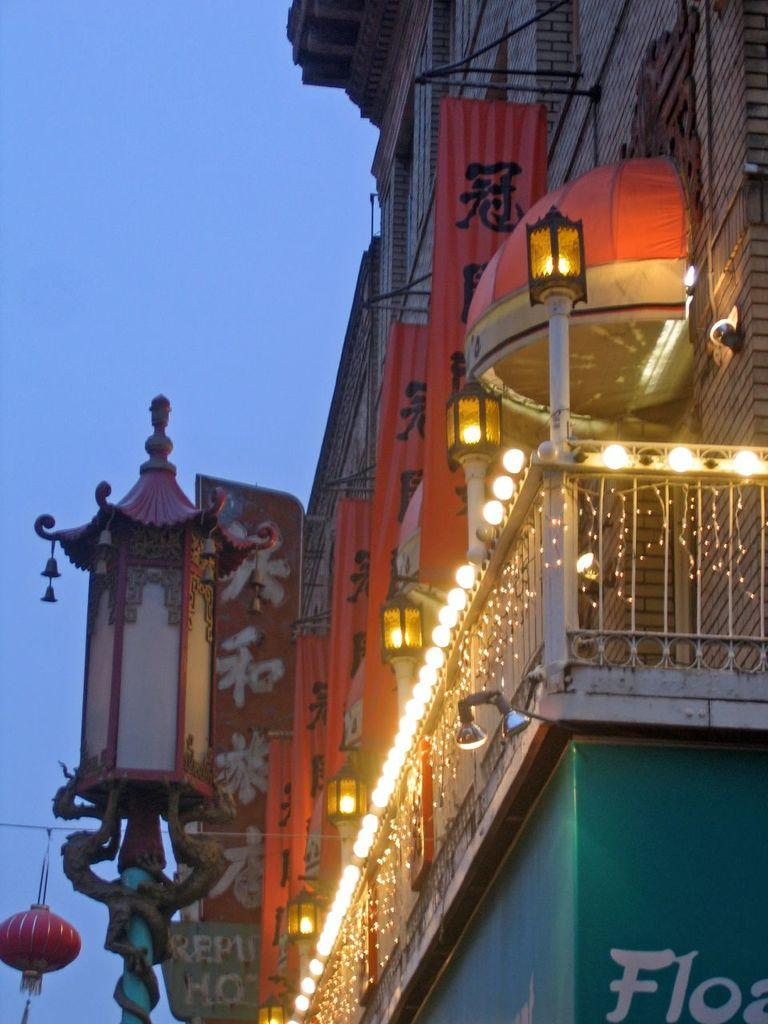What type of structure is partially visible in the image? There is a part of a building in the image. What feature can be seen on the building? The building has railing. Are there any additional decorative elements on the building? Yes, the building has decorative lights. What other object is present in the image? There is a pole with a lamp in the image. What can be seen in the background of the image? The sky is visible in the image. What type of leaf is falling from the sky in the image? There are no leaves visible in the image; only the sky is visible in the background. Is there a locket hanging from the decorative lights on the building? There is no mention of a locket in the image; only the building, railing, decorative lights, pole with a lamp, and sky are described. 